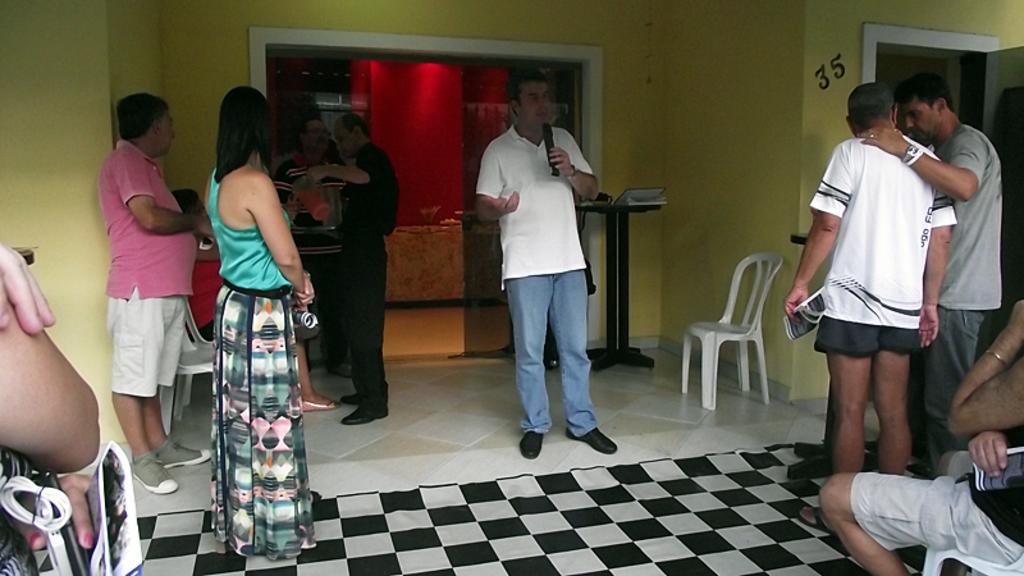Describe this image in one or two sentences. In this image I can see a woman wearing green and black dress is standing and a person pink t shirt, short and shoe and another person wearing white t shirt, blue jeans and black shoe is standing and holding a black colored microphone in his hand. To the right side of the image I can see few other persons standing and a person sitting. In the background I can see few persons standing, the wall, a glass door, a stand with few objects on it and a chair which is white in color. 